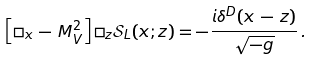<formula> <loc_0><loc_0><loc_500><loc_500>\left [ \square _ { x } \, - \, M _ { V } ^ { 2 } \right ] \square _ { z } \mathcal { S } _ { L } ( x ; z ) = - \frac { i \delta ^ { D } ( x \, - \, z ) } { \sqrt { - g } } \, .</formula> 